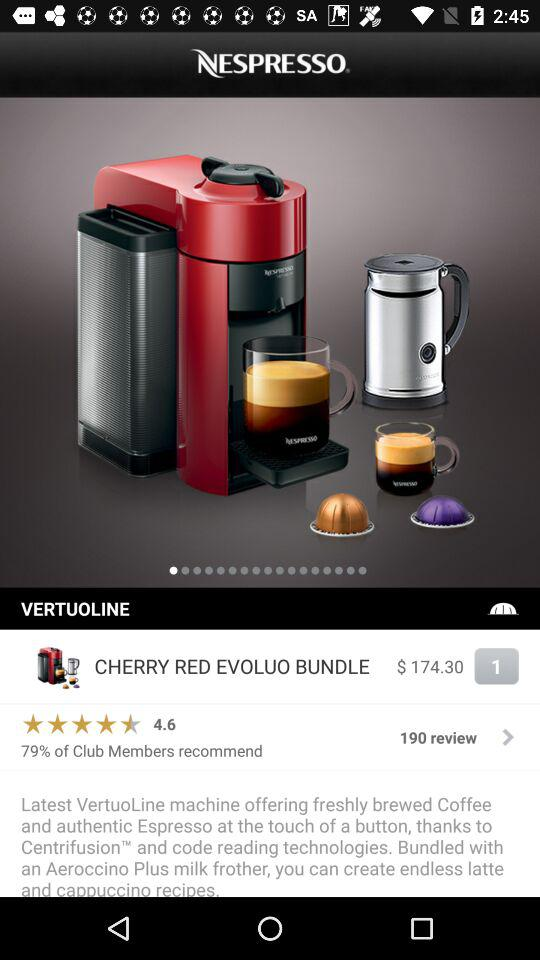How much is the cost of the product? The cost of the product is $174.30. 